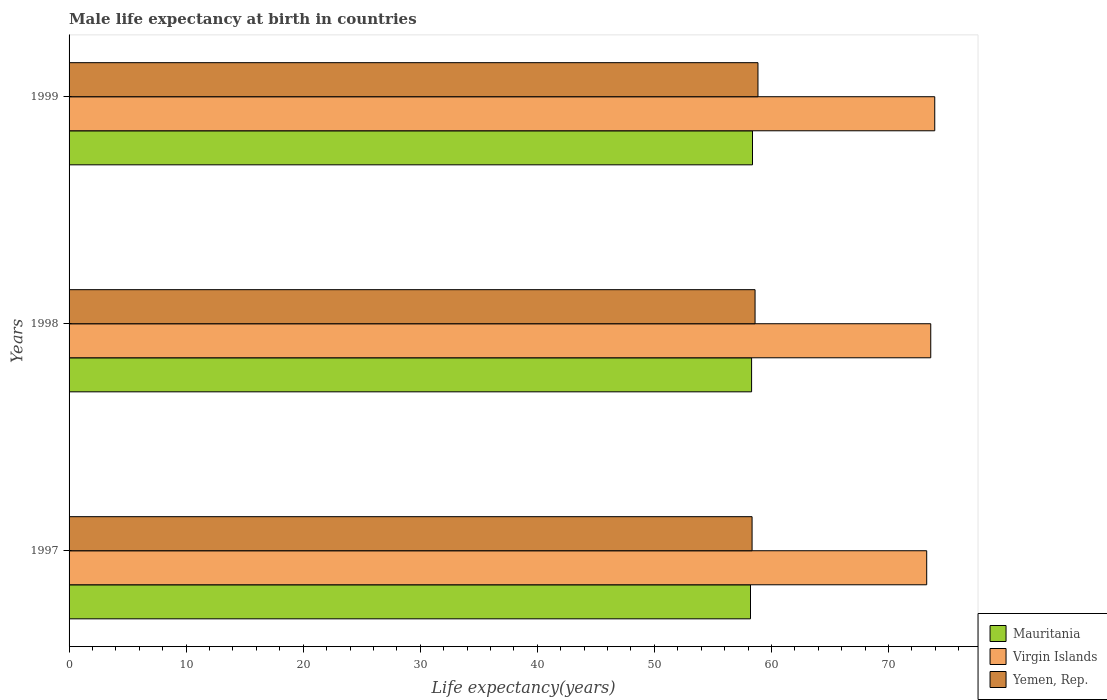How many different coloured bars are there?
Your answer should be compact. 3. How many bars are there on the 1st tick from the top?
Your answer should be compact. 3. How many bars are there on the 1st tick from the bottom?
Give a very brief answer. 3. What is the label of the 3rd group of bars from the top?
Provide a short and direct response. 1997. In how many cases, is the number of bars for a given year not equal to the number of legend labels?
Provide a succinct answer. 0. What is the male life expectancy at birth in Yemen, Rep. in 1997?
Provide a succinct answer. 58.35. Across all years, what is the maximum male life expectancy at birth in Mauritania?
Your response must be concise. 58.38. Across all years, what is the minimum male life expectancy at birth in Mauritania?
Keep it short and to the point. 58.21. In which year was the male life expectancy at birth in Virgin Islands minimum?
Provide a succinct answer. 1997. What is the total male life expectancy at birth in Yemen, Rep. in the graph?
Provide a succinct answer. 175.8. What is the difference between the male life expectancy at birth in Mauritania in 1997 and that in 1998?
Provide a succinct answer. -0.09. What is the difference between the male life expectancy at birth in Mauritania in 1997 and the male life expectancy at birth in Yemen, Rep. in 1999?
Your response must be concise. -0.64. What is the average male life expectancy at birth in Yemen, Rep. per year?
Ensure brevity in your answer.  58.6. In the year 1998, what is the difference between the male life expectancy at birth in Yemen, Rep. and male life expectancy at birth in Mauritania?
Your response must be concise. 0.3. What is the ratio of the male life expectancy at birth in Yemen, Rep. in 1998 to that in 1999?
Your response must be concise. 1. Is the male life expectancy at birth in Virgin Islands in 1998 less than that in 1999?
Provide a succinct answer. Yes. Is the difference between the male life expectancy at birth in Yemen, Rep. in 1998 and 1999 greater than the difference between the male life expectancy at birth in Mauritania in 1998 and 1999?
Your response must be concise. No. What is the difference between the highest and the second highest male life expectancy at birth in Virgin Islands?
Offer a very short reply. 0.34. What is the difference between the highest and the lowest male life expectancy at birth in Mauritania?
Make the answer very short. 0.17. What does the 2nd bar from the top in 1997 represents?
Your answer should be compact. Virgin Islands. What does the 2nd bar from the bottom in 1999 represents?
Your response must be concise. Virgin Islands. Is it the case that in every year, the sum of the male life expectancy at birth in Mauritania and male life expectancy at birth in Yemen, Rep. is greater than the male life expectancy at birth in Virgin Islands?
Offer a terse response. Yes. Are all the bars in the graph horizontal?
Make the answer very short. Yes. Are the values on the major ticks of X-axis written in scientific E-notation?
Keep it short and to the point. No. How are the legend labels stacked?
Make the answer very short. Vertical. What is the title of the graph?
Offer a very short reply. Male life expectancy at birth in countries. What is the label or title of the X-axis?
Your response must be concise. Life expectancy(years). What is the label or title of the Y-axis?
Make the answer very short. Years. What is the Life expectancy(years) of Mauritania in 1997?
Your answer should be compact. 58.21. What is the Life expectancy(years) in Virgin Islands in 1997?
Make the answer very short. 73.27. What is the Life expectancy(years) of Yemen, Rep. in 1997?
Offer a very short reply. 58.35. What is the Life expectancy(years) of Mauritania in 1998?
Keep it short and to the point. 58.31. What is the Life expectancy(years) in Virgin Islands in 1998?
Ensure brevity in your answer.  73.61. What is the Life expectancy(years) of Yemen, Rep. in 1998?
Your answer should be very brief. 58.6. What is the Life expectancy(years) in Mauritania in 1999?
Your answer should be compact. 58.38. What is the Life expectancy(years) of Virgin Islands in 1999?
Keep it short and to the point. 73.95. What is the Life expectancy(years) of Yemen, Rep. in 1999?
Make the answer very short. 58.85. Across all years, what is the maximum Life expectancy(years) in Mauritania?
Keep it short and to the point. 58.38. Across all years, what is the maximum Life expectancy(years) of Virgin Islands?
Keep it short and to the point. 73.95. Across all years, what is the maximum Life expectancy(years) in Yemen, Rep.?
Provide a succinct answer. 58.85. Across all years, what is the minimum Life expectancy(years) in Mauritania?
Make the answer very short. 58.21. Across all years, what is the minimum Life expectancy(years) of Virgin Islands?
Make the answer very short. 73.27. Across all years, what is the minimum Life expectancy(years) of Yemen, Rep.?
Provide a short and direct response. 58.35. What is the total Life expectancy(years) of Mauritania in the graph?
Ensure brevity in your answer.  174.9. What is the total Life expectancy(years) of Virgin Islands in the graph?
Keep it short and to the point. 220.83. What is the total Life expectancy(years) in Yemen, Rep. in the graph?
Make the answer very short. 175.8. What is the difference between the Life expectancy(years) of Mauritania in 1997 and that in 1998?
Provide a succinct answer. -0.09. What is the difference between the Life expectancy(years) in Virgin Islands in 1997 and that in 1998?
Provide a short and direct response. -0.35. What is the difference between the Life expectancy(years) of Yemen, Rep. in 1997 and that in 1998?
Provide a succinct answer. -0.26. What is the difference between the Life expectancy(years) of Mauritania in 1997 and that in 1999?
Ensure brevity in your answer.  -0.17. What is the difference between the Life expectancy(years) in Virgin Islands in 1997 and that in 1999?
Your answer should be compact. -0.69. What is the difference between the Life expectancy(years) in Yemen, Rep. in 1997 and that in 1999?
Provide a succinct answer. -0.5. What is the difference between the Life expectancy(years) in Mauritania in 1998 and that in 1999?
Make the answer very short. -0.08. What is the difference between the Life expectancy(years) of Virgin Islands in 1998 and that in 1999?
Offer a terse response. -0.34. What is the difference between the Life expectancy(years) in Yemen, Rep. in 1998 and that in 1999?
Your answer should be very brief. -0.25. What is the difference between the Life expectancy(years) of Mauritania in 1997 and the Life expectancy(years) of Virgin Islands in 1998?
Give a very brief answer. -15.4. What is the difference between the Life expectancy(years) of Mauritania in 1997 and the Life expectancy(years) of Yemen, Rep. in 1998?
Provide a short and direct response. -0.39. What is the difference between the Life expectancy(years) of Virgin Islands in 1997 and the Life expectancy(years) of Yemen, Rep. in 1998?
Your answer should be very brief. 14.66. What is the difference between the Life expectancy(years) in Mauritania in 1997 and the Life expectancy(years) in Virgin Islands in 1999?
Ensure brevity in your answer.  -15.74. What is the difference between the Life expectancy(years) of Mauritania in 1997 and the Life expectancy(years) of Yemen, Rep. in 1999?
Offer a terse response. -0.64. What is the difference between the Life expectancy(years) of Virgin Islands in 1997 and the Life expectancy(years) of Yemen, Rep. in 1999?
Keep it short and to the point. 14.41. What is the difference between the Life expectancy(years) in Mauritania in 1998 and the Life expectancy(years) in Virgin Islands in 1999?
Your answer should be compact. -15.65. What is the difference between the Life expectancy(years) of Mauritania in 1998 and the Life expectancy(years) of Yemen, Rep. in 1999?
Make the answer very short. -0.54. What is the difference between the Life expectancy(years) in Virgin Islands in 1998 and the Life expectancy(years) in Yemen, Rep. in 1999?
Give a very brief answer. 14.76. What is the average Life expectancy(years) of Mauritania per year?
Provide a short and direct response. 58.3. What is the average Life expectancy(years) in Virgin Islands per year?
Offer a very short reply. 73.61. What is the average Life expectancy(years) of Yemen, Rep. per year?
Your answer should be very brief. 58.6. In the year 1997, what is the difference between the Life expectancy(years) of Mauritania and Life expectancy(years) of Virgin Islands?
Ensure brevity in your answer.  -15.05. In the year 1997, what is the difference between the Life expectancy(years) in Mauritania and Life expectancy(years) in Yemen, Rep.?
Offer a terse response. -0.13. In the year 1997, what is the difference between the Life expectancy(years) of Virgin Islands and Life expectancy(years) of Yemen, Rep.?
Your answer should be compact. 14.92. In the year 1998, what is the difference between the Life expectancy(years) in Mauritania and Life expectancy(years) in Virgin Islands?
Ensure brevity in your answer.  -15.3. In the year 1998, what is the difference between the Life expectancy(years) of Mauritania and Life expectancy(years) of Yemen, Rep.?
Ensure brevity in your answer.  -0.3. In the year 1998, what is the difference between the Life expectancy(years) of Virgin Islands and Life expectancy(years) of Yemen, Rep.?
Offer a very short reply. 15.01. In the year 1999, what is the difference between the Life expectancy(years) in Mauritania and Life expectancy(years) in Virgin Islands?
Provide a succinct answer. -15.57. In the year 1999, what is the difference between the Life expectancy(years) in Mauritania and Life expectancy(years) in Yemen, Rep.?
Offer a very short reply. -0.47. In the year 1999, what is the difference between the Life expectancy(years) in Virgin Islands and Life expectancy(years) in Yemen, Rep.?
Your response must be concise. 15.1. What is the ratio of the Life expectancy(years) in Mauritania in 1997 to that in 1998?
Provide a short and direct response. 1. What is the ratio of the Life expectancy(years) in Virgin Islands in 1997 to that in 1998?
Provide a short and direct response. 1. What is the ratio of the Life expectancy(years) of Yemen, Rep. in 1997 to that in 1998?
Your response must be concise. 1. What is the ratio of the Life expectancy(years) in Yemen, Rep. in 1998 to that in 1999?
Provide a short and direct response. 1. What is the difference between the highest and the second highest Life expectancy(years) in Mauritania?
Offer a terse response. 0.08. What is the difference between the highest and the second highest Life expectancy(years) of Virgin Islands?
Give a very brief answer. 0.34. What is the difference between the highest and the second highest Life expectancy(years) of Yemen, Rep.?
Provide a short and direct response. 0.25. What is the difference between the highest and the lowest Life expectancy(years) in Mauritania?
Provide a short and direct response. 0.17. What is the difference between the highest and the lowest Life expectancy(years) of Virgin Islands?
Ensure brevity in your answer.  0.69. What is the difference between the highest and the lowest Life expectancy(years) in Yemen, Rep.?
Your answer should be compact. 0.5. 